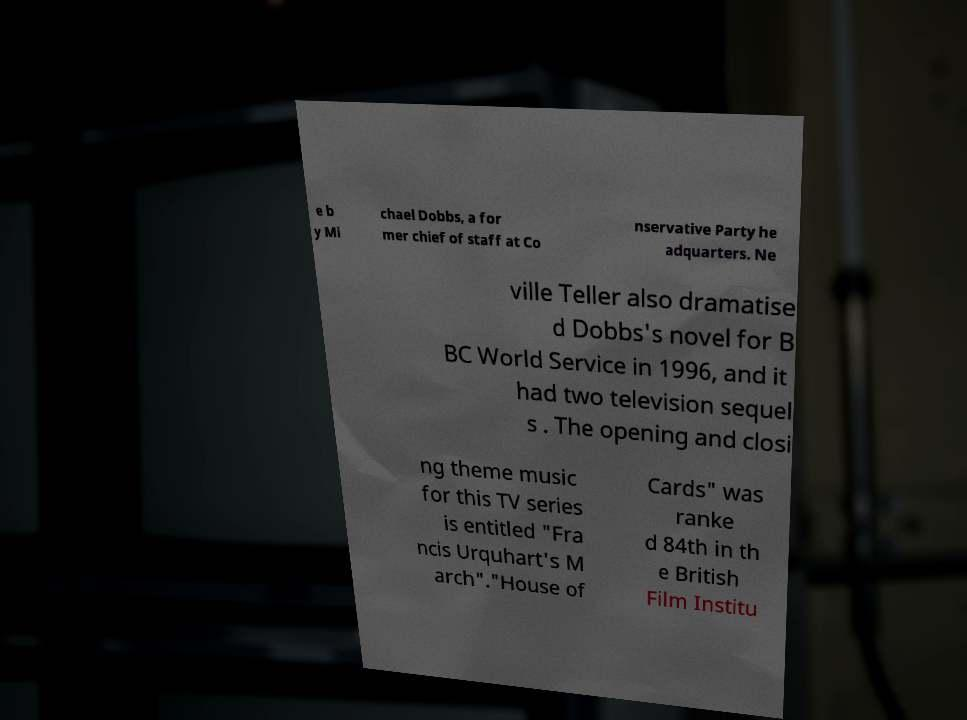I need the written content from this picture converted into text. Can you do that? e b y Mi chael Dobbs, a for mer chief of staff at Co nservative Party he adquarters. Ne ville Teller also dramatise d Dobbs's novel for B BC World Service in 1996, and it had two television sequel s . The opening and closi ng theme music for this TV series is entitled "Fra ncis Urquhart's M arch"."House of Cards" was ranke d 84th in th e British Film Institu 